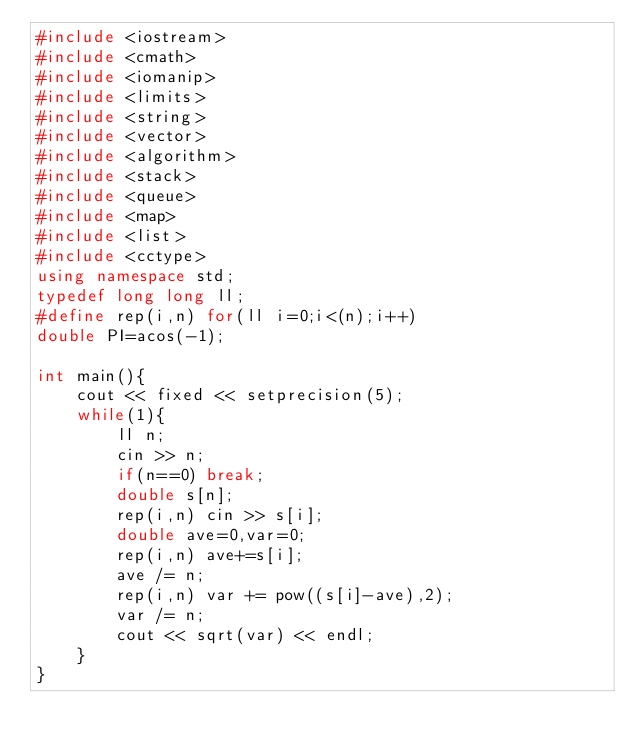<code> <loc_0><loc_0><loc_500><loc_500><_C++_>#include <iostream>
#include <cmath>
#include <iomanip>
#include <limits>
#include <string>
#include <vector>
#include <algorithm>
#include <stack>
#include <queue>
#include <map>
#include <list>
#include <cctype>
using namespace std;
typedef long long ll;
#define rep(i,n) for(ll i=0;i<(n);i++)
double PI=acos(-1);

int main(){
    cout << fixed << setprecision(5);
    while(1){
        ll n;
        cin >> n;
        if(n==0) break;
        double s[n];
        rep(i,n) cin >> s[i];
        double ave=0,var=0;
        rep(i,n) ave+=s[i];
        ave /= n;
        rep(i,n) var += pow((s[i]-ave),2);
        var /= n;
        cout << sqrt(var) << endl;
    }
}
</code> 